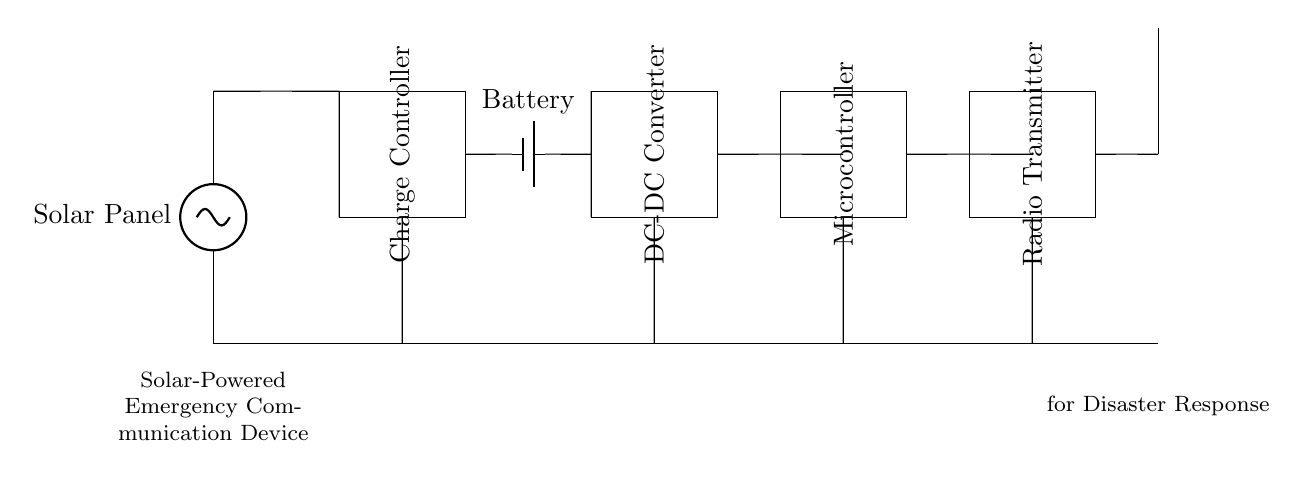What is the primary power source for this device? The primary power source is the Solar Panel, which converts solar energy into electrical energy. This is indicated at the beginning of the circuit diagram.
Answer: Solar Panel What component is used to store energy? The energy storage component is the Battery, which is clearly labeled in the circuit diagram. It is responsible for storing energy generated by the solar panel.
Answer: Battery What does the DC-DC Converter do? The DC-DC Converter is used to regulate the voltage and current levels, ensuring that the downstream components receive the appropriate power supply. Its role is essential in adapting the energy for the microcontroller and transmitter.
Answer: Regulate voltage What type of communication does this device utilize? The device utilizes radio communication, as indicated by the Radio Transmitter component, facilitating wireless communication during emergencies.
Answer: Radio How many components are in the circuit? The circuit contains six main components: Solar Panel, Charge Controller, Battery, DC-DC Converter, Microcontroller, and Radio Transmitter, excluding the Antenna.
Answer: Six What is the purpose of the Charge Controller in this circuit? The Charge Controller is crucial for managing the charge and discharge cycles of the battery, preventing overcharging and optimizing the lifespan of the battery. This component ensures efficient energy management in solar-powered devices.
Answer: Manage battery charge What does the antenna do in this circuit? The Antenna converts electrical signals into radio waves for transmission, allowing the device to communicate with other units or receivers effectively, which is vital during disaster response situations.
Answer: Transmit signals 